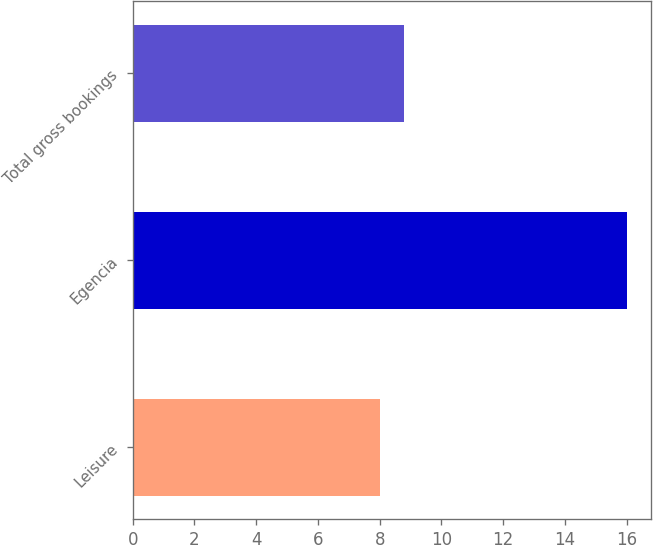Convert chart. <chart><loc_0><loc_0><loc_500><loc_500><bar_chart><fcel>Leisure<fcel>Egencia<fcel>Total gross bookings<nl><fcel>8<fcel>16<fcel>8.8<nl></chart> 